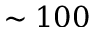<formula> <loc_0><loc_0><loc_500><loc_500>\sim 1 0 0</formula> 